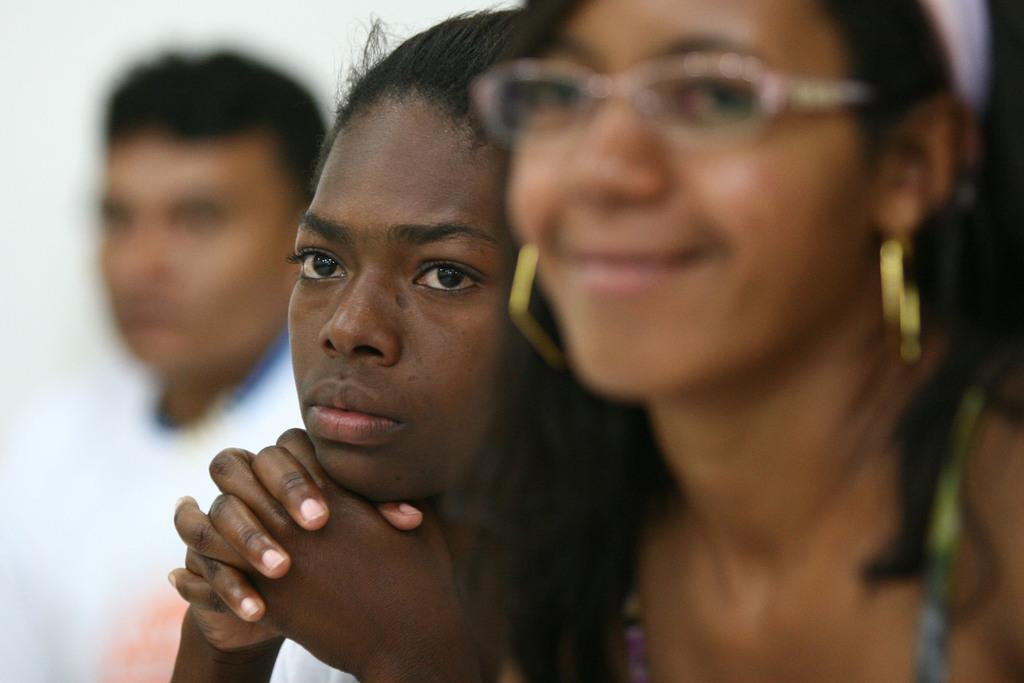How many people are in the image? There are three persons in the image. Can you describe any accessories worn by the persons? One of the persons is wearing glasses, and another person is wearing earrings. What type of bag is the person with glasses holding in the image? There is no bag visible in the image. Can you describe the teeth of the person wearing earrings in the image? There is no information about the person's teeth in the image. 